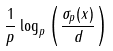Convert formula to latex. <formula><loc_0><loc_0><loc_500><loc_500>\frac { 1 } { p } \log _ { p } \left ( \frac { \sigma _ { p } ( x ) } { d } \right )</formula> 